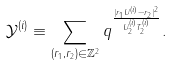Convert formula to latex. <formula><loc_0><loc_0><loc_500><loc_500>\mathcal { Y } ^ { ( i ) } \equiv \sum _ { ( r _ { 1 } , r _ { 2 } ) \in \mathbb { Z } ^ { 2 } } q ^ { \frac { | r _ { 1 } U ^ { ( i ) } - r _ { 2 } | ^ { 2 } } { U _ { 2 } ^ { ( i ) } T _ { 2 } ^ { ( i ) } } } .</formula> 